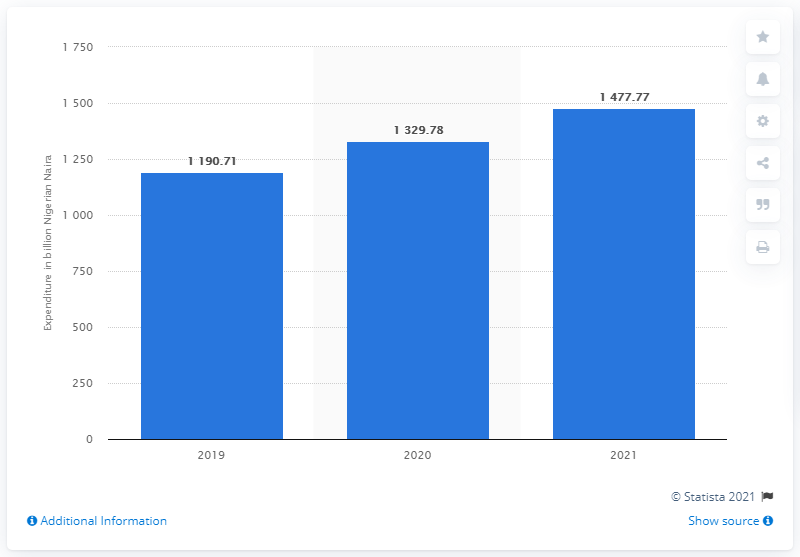Indicate a few pertinent items in this graphic. According to projections, Nigeria's expenditure on healthcare is expected to increase in the year 2021. 